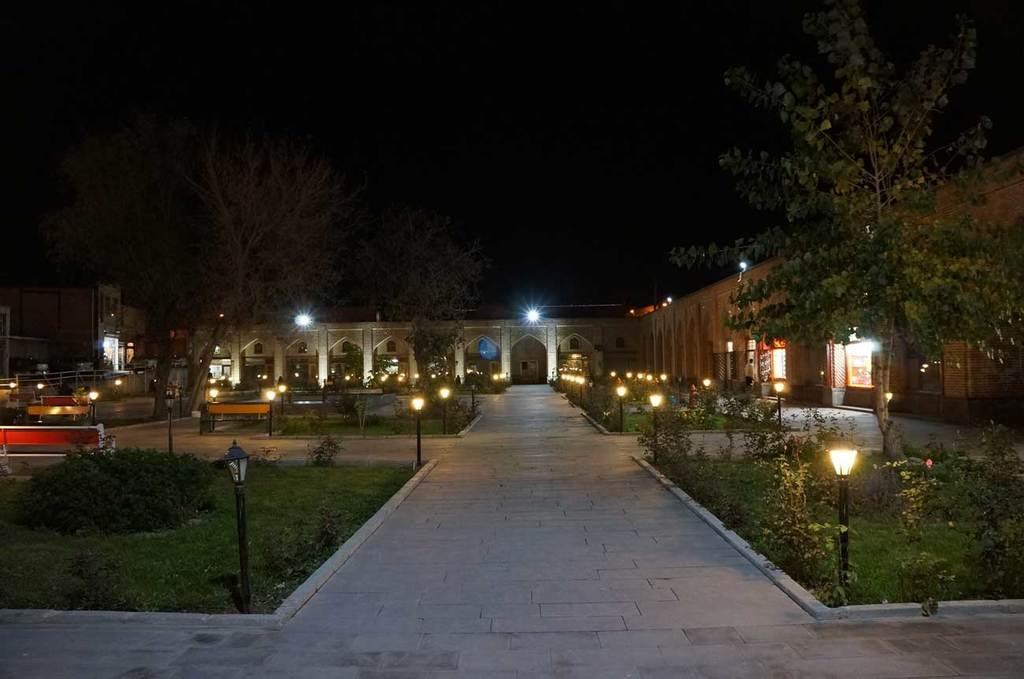How would you summarize this image in a sentence or two? In this picture I can see the buildings, trees, plants, grass and lights. On the left I can see the benches and fencing. At the top I can see the darkness. In the center I can see the street walk. 